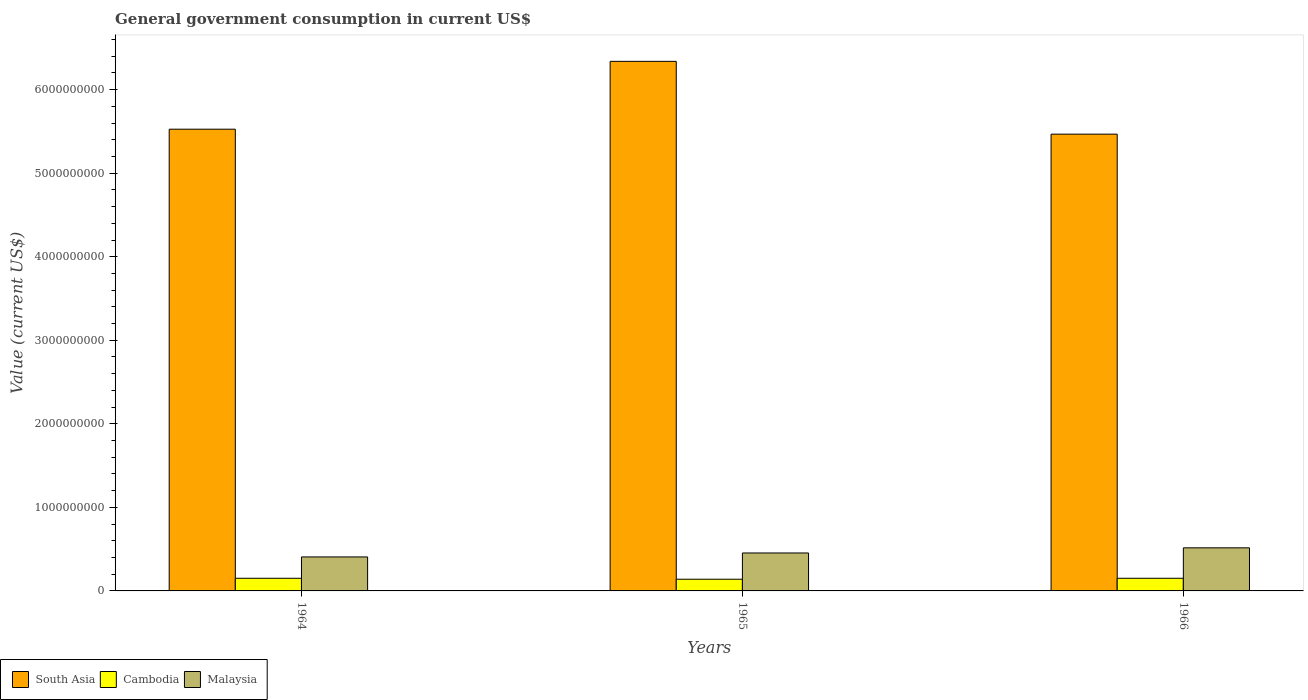How many bars are there on the 1st tick from the right?
Give a very brief answer. 3. What is the label of the 1st group of bars from the left?
Offer a very short reply. 1964. What is the government conusmption in South Asia in 1966?
Your answer should be compact. 5.47e+09. Across all years, what is the maximum government conusmption in Malaysia?
Provide a short and direct response. 5.16e+08. Across all years, what is the minimum government conusmption in South Asia?
Offer a very short reply. 5.47e+09. In which year was the government conusmption in Cambodia maximum?
Give a very brief answer. 1964. In which year was the government conusmption in Malaysia minimum?
Provide a succinct answer. 1964. What is the total government conusmption in Malaysia in the graph?
Your answer should be very brief. 1.38e+09. What is the difference between the government conusmption in Cambodia in 1965 and that in 1966?
Your response must be concise. -1.14e+07. What is the difference between the government conusmption in South Asia in 1965 and the government conusmption in Malaysia in 1964?
Your response must be concise. 5.93e+09. What is the average government conusmption in Cambodia per year?
Your answer should be compact. 1.48e+08. In the year 1965, what is the difference between the government conusmption in South Asia and government conusmption in Cambodia?
Make the answer very short. 6.20e+09. In how many years, is the government conusmption in South Asia greater than 2200000000 US$?
Give a very brief answer. 3. What is the ratio of the government conusmption in Malaysia in 1964 to that in 1966?
Keep it short and to the point. 0.79. Is the government conusmption in Cambodia in 1964 less than that in 1965?
Provide a succinct answer. No. What is the difference between the highest and the second highest government conusmption in Malaysia?
Offer a very short reply. 6.15e+07. What is the difference between the highest and the lowest government conusmption in South Asia?
Provide a succinct answer. 8.71e+08. Is the sum of the government conusmption in South Asia in 1964 and 1965 greater than the maximum government conusmption in Cambodia across all years?
Offer a very short reply. Yes. What does the 3rd bar from the left in 1964 represents?
Offer a terse response. Malaysia. Is it the case that in every year, the sum of the government conusmption in South Asia and government conusmption in Malaysia is greater than the government conusmption in Cambodia?
Keep it short and to the point. Yes. How many bars are there?
Keep it short and to the point. 9. Are all the bars in the graph horizontal?
Provide a short and direct response. No. How many years are there in the graph?
Offer a very short reply. 3. What is the difference between two consecutive major ticks on the Y-axis?
Provide a succinct answer. 1.00e+09. Are the values on the major ticks of Y-axis written in scientific E-notation?
Provide a short and direct response. No. Where does the legend appear in the graph?
Keep it short and to the point. Bottom left. What is the title of the graph?
Your response must be concise. General government consumption in current US$. What is the label or title of the Y-axis?
Give a very brief answer. Value (current US$). What is the Value (current US$) in South Asia in 1964?
Offer a very short reply. 5.53e+09. What is the Value (current US$) of Cambodia in 1964?
Make the answer very short. 1.51e+08. What is the Value (current US$) of Malaysia in 1964?
Offer a terse response. 4.07e+08. What is the Value (current US$) in South Asia in 1965?
Make the answer very short. 6.34e+09. What is the Value (current US$) in Cambodia in 1965?
Provide a succinct answer. 1.40e+08. What is the Value (current US$) in Malaysia in 1965?
Keep it short and to the point. 4.54e+08. What is the Value (current US$) of South Asia in 1966?
Provide a succinct answer. 5.47e+09. What is the Value (current US$) of Cambodia in 1966?
Keep it short and to the point. 1.51e+08. What is the Value (current US$) in Malaysia in 1966?
Ensure brevity in your answer.  5.16e+08. Across all years, what is the maximum Value (current US$) in South Asia?
Offer a very short reply. 6.34e+09. Across all years, what is the maximum Value (current US$) of Cambodia?
Your response must be concise. 1.51e+08. Across all years, what is the maximum Value (current US$) in Malaysia?
Offer a very short reply. 5.16e+08. Across all years, what is the minimum Value (current US$) in South Asia?
Keep it short and to the point. 5.47e+09. Across all years, what is the minimum Value (current US$) of Cambodia?
Ensure brevity in your answer.  1.40e+08. Across all years, what is the minimum Value (current US$) in Malaysia?
Offer a terse response. 4.07e+08. What is the total Value (current US$) in South Asia in the graph?
Your answer should be very brief. 1.73e+1. What is the total Value (current US$) of Cambodia in the graph?
Keep it short and to the point. 4.43e+08. What is the total Value (current US$) in Malaysia in the graph?
Provide a succinct answer. 1.38e+09. What is the difference between the Value (current US$) of South Asia in 1964 and that in 1965?
Make the answer very short. -8.12e+08. What is the difference between the Value (current US$) in Cambodia in 1964 and that in 1965?
Provide a short and direct response. 1.14e+07. What is the difference between the Value (current US$) of Malaysia in 1964 and that in 1965?
Your answer should be very brief. -4.73e+07. What is the difference between the Value (current US$) of South Asia in 1964 and that in 1966?
Give a very brief answer. 5.93e+07. What is the difference between the Value (current US$) of Cambodia in 1964 and that in 1966?
Ensure brevity in your answer.  0. What is the difference between the Value (current US$) of Malaysia in 1964 and that in 1966?
Keep it short and to the point. -1.09e+08. What is the difference between the Value (current US$) in South Asia in 1965 and that in 1966?
Your response must be concise. 8.71e+08. What is the difference between the Value (current US$) in Cambodia in 1965 and that in 1966?
Keep it short and to the point. -1.14e+07. What is the difference between the Value (current US$) in Malaysia in 1965 and that in 1966?
Ensure brevity in your answer.  -6.15e+07. What is the difference between the Value (current US$) in South Asia in 1964 and the Value (current US$) in Cambodia in 1965?
Your response must be concise. 5.39e+09. What is the difference between the Value (current US$) in South Asia in 1964 and the Value (current US$) in Malaysia in 1965?
Provide a short and direct response. 5.07e+09. What is the difference between the Value (current US$) of Cambodia in 1964 and the Value (current US$) of Malaysia in 1965?
Your answer should be very brief. -3.03e+08. What is the difference between the Value (current US$) of South Asia in 1964 and the Value (current US$) of Cambodia in 1966?
Offer a very short reply. 5.38e+09. What is the difference between the Value (current US$) of South Asia in 1964 and the Value (current US$) of Malaysia in 1966?
Give a very brief answer. 5.01e+09. What is the difference between the Value (current US$) in Cambodia in 1964 and the Value (current US$) in Malaysia in 1966?
Ensure brevity in your answer.  -3.64e+08. What is the difference between the Value (current US$) of South Asia in 1965 and the Value (current US$) of Cambodia in 1966?
Ensure brevity in your answer.  6.19e+09. What is the difference between the Value (current US$) in South Asia in 1965 and the Value (current US$) in Malaysia in 1966?
Provide a succinct answer. 5.82e+09. What is the difference between the Value (current US$) of Cambodia in 1965 and the Value (current US$) of Malaysia in 1966?
Offer a terse response. -3.76e+08. What is the average Value (current US$) of South Asia per year?
Ensure brevity in your answer.  5.78e+09. What is the average Value (current US$) in Cambodia per year?
Ensure brevity in your answer.  1.48e+08. What is the average Value (current US$) of Malaysia per year?
Provide a succinct answer. 4.59e+08. In the year 1964, what is the difference between the Value (current US$) in South Asia and Value (current US$) in Cambodia?
Provide a short and direct response. 5.38e+09. In the year 1964, what is the difference between the Value (current US$) in South Asia and Value (current US$) in Malaysia?
Provide a succinct answer. 5.12e+09. In the year 1964, what is the difference between the Value (current US$) of Cambodia and Value (current US$) of Malaysia?
Your response must be concise. -2.55e+08. In the year 1965, what is the difference between the Value (current US$) of South Asia and Value (current US$) of Cambodia?
Your response must be concise. 6.20e+09. In the year 1965, what is the difference between the Value (current US$) of South Asia and Value (current US$) of Malaysia?
Provide a succinct answer. 5.88e+09. In the year 1965, what is the difference between the Value (current US$) in Cambodia and Value (current US$) in Malaysia?
Your response must be concise. -3.14e+08. In the year 1966, what is the difference between the Value (current US$) in South Asia and Value (current US$) in Cambodia?
Offer a very short reply. 5.32e+09. In the year 1966, what is the difference between the Value (current US$) of South Asia and Value (current US$) of Malaysia?
Your answer should be compact. 4.95e+09. In the year 1966, what is the difference between the Value (current US$) in Cambodia and Value (current US$) in Malaysia?
Give a very brief answer. -3.64e+08. What is the ratio of the Value (current US$) in South Asia in 1964 to that in 1965?
Provide a short and direct response. 0.87. What is the ratio of the Value (current US$) of Cambodia in 1964 to that in 1965?
Your response must be concise. 1.08. What is the ratio of the Value (current US$) in Malaysia in 1964 to that in 1965?
Provide a succinct answer. 0.9. What is the ratio of the Value (current US$) of South Asia in 1964 to that in 1966?
Ensure brevity in your answer.  1.01. What is the ratio of the Value (current US$) in Cambodia in 1964 to that in 1966?
Provide a succinct answer. 1. What is the ratio of the Value (current US$) in Malaysia in 1964 to that in 1966?
Keep it short and to the point. 0.79. What is the ratio of the Value (current US$) of South Asia in 1965 to that in 1966?
Give a very brief answer. 1.16. What is the ratio of the Value (current US$) in Cambodia in 1965 to that in 1966?
Your answer should be very brief. 0.92. What is the ratio of the Value (current US$) of Malaysia in 1965 to that in 1966?
Offer a very short reply. 0.88. What is the difference between the highest and the second highest Value (current US$) in South Asia?
Offer a terse response. 8.12e+08. What is the difference between the highest and the second highest Value (current US$) in Cambodia?
Your answer should be very brief. 0. What is the difference between the highest and the second highest Value (current US$) of Malaysia?
Your response must be concise. 6.15e+07. What is the difference between the highest and the lowest Value (current US$) in South Asia?
Offer a terse response. 8.71e+08. What is the difference between the highest and the lowest Value (current US$) in Cambodia?
Your answer should be compact. 1.14e+07. What is the difference between the highest and the lowest Value (current US$) of Malaysia?
Give a very brief answer. 1.09e+08. 